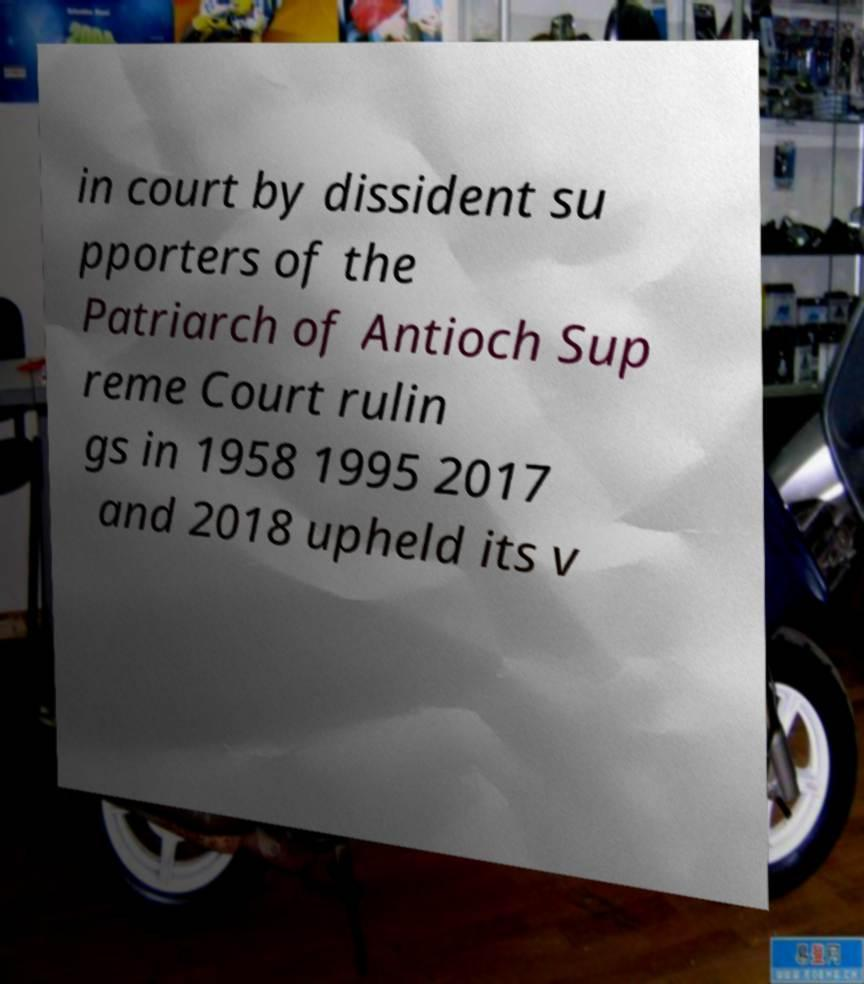I need the written content from this picture converted into text. Can you do that? in court by dissident su pporters of the Patriarch of Antioch Sup reme Court rulin gs in 1958 1995 2017 and 2018 upheld its v 